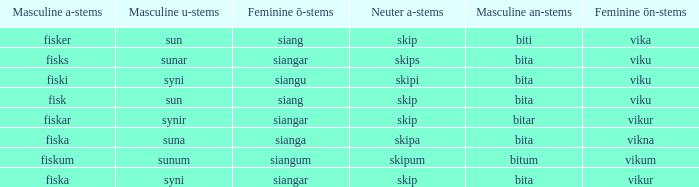What is the masculine u form for the old swedish expression with a neuter a form of skipum? Sunum. 